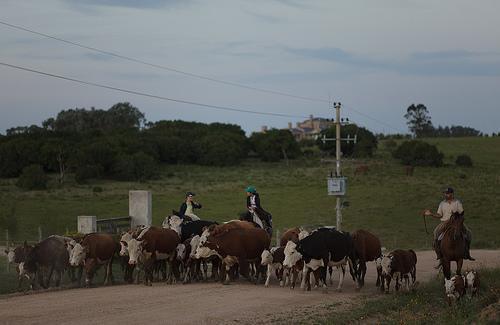How many people are in the photo?
Give a very brief answer. 3. 